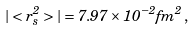<formula> <loc_0><loc_0><loc_500><loc_500>| < r _ { s } ^ { 2 } > | = 7 . 9 7 \times 1 0 ^ { - 2 } f m ^ { 2 } \, ,</formula> 